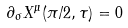Convert formula to latex. <formula><loc_0><loc_0><loc_500><loc_500>\partial _ { \sigma } X ^ { \mu } ( \pi / 2 , \tau ) = 0</formula> 